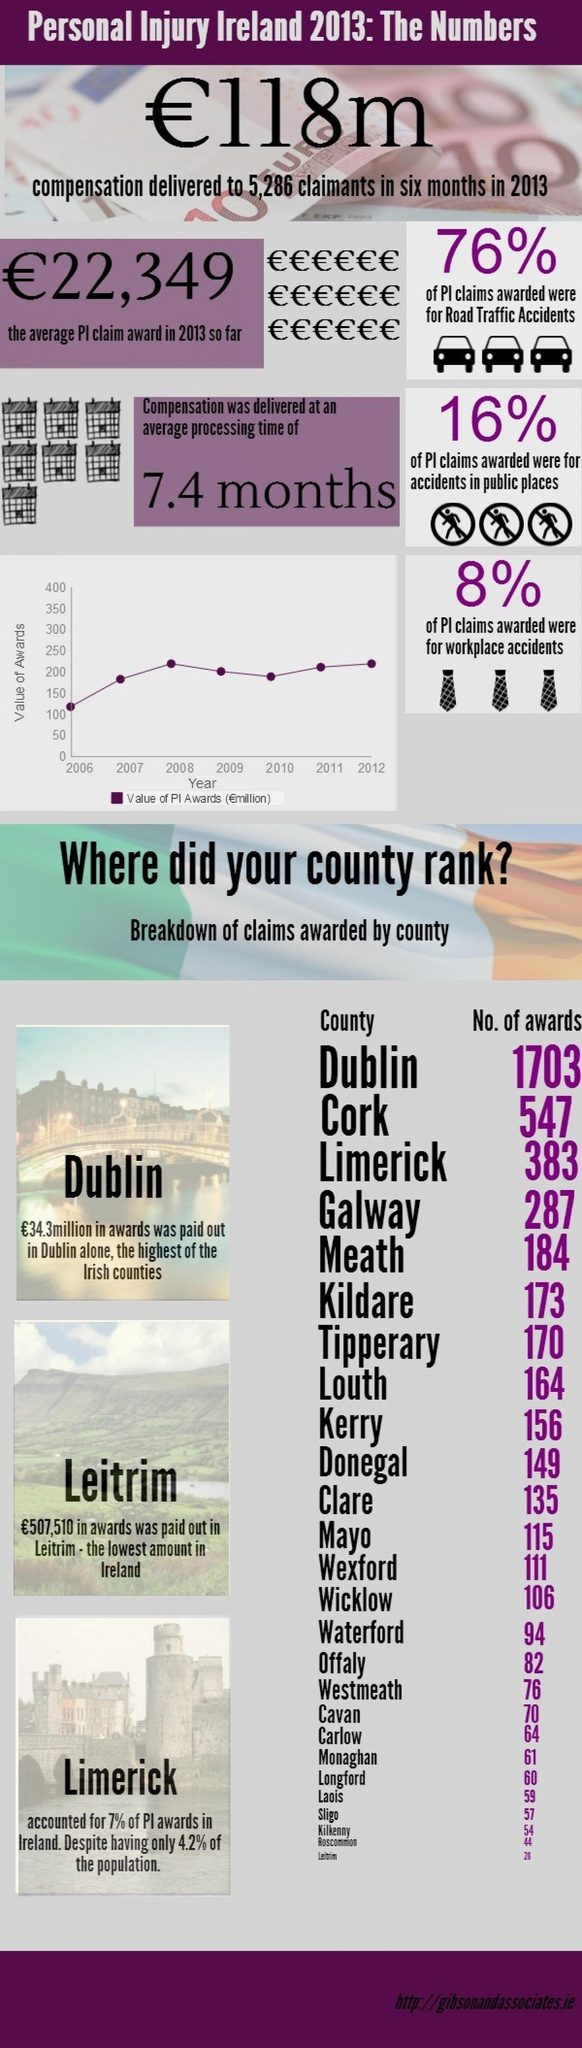Which county has 4.2% of population of Ireland?
Answer the question with a short phrase. Limerick How many more awards did Dublin award than Limerick? 1,320 What came in second in the most Pl claims awarded for in 2013? accidents in public places What was the most Pl claims awarded for in 2013? Road traffic accidents How many more awards did Clare award than Wicklow? 29 Which county in Ireland came in seventh in awarding most number of claims? Tipperary What did 1703 awards awarded by Dublin amount to in Euros? 34.3million Which county in Ireland came in second in awarding most number of claims? Cork Which county in Ireland came in tenth in awarding most number of claims? Donegal What was the average processing time to deliver compensation? 7.4 months How many more awards did Clare award than Offaly? 53 Which county awarded the lowest amount in Ireland? Leitrim Which county in Ireland came in fifth in awarding most number of claims? Meath How many more awards did Dublin award than Kildare? 1,530 